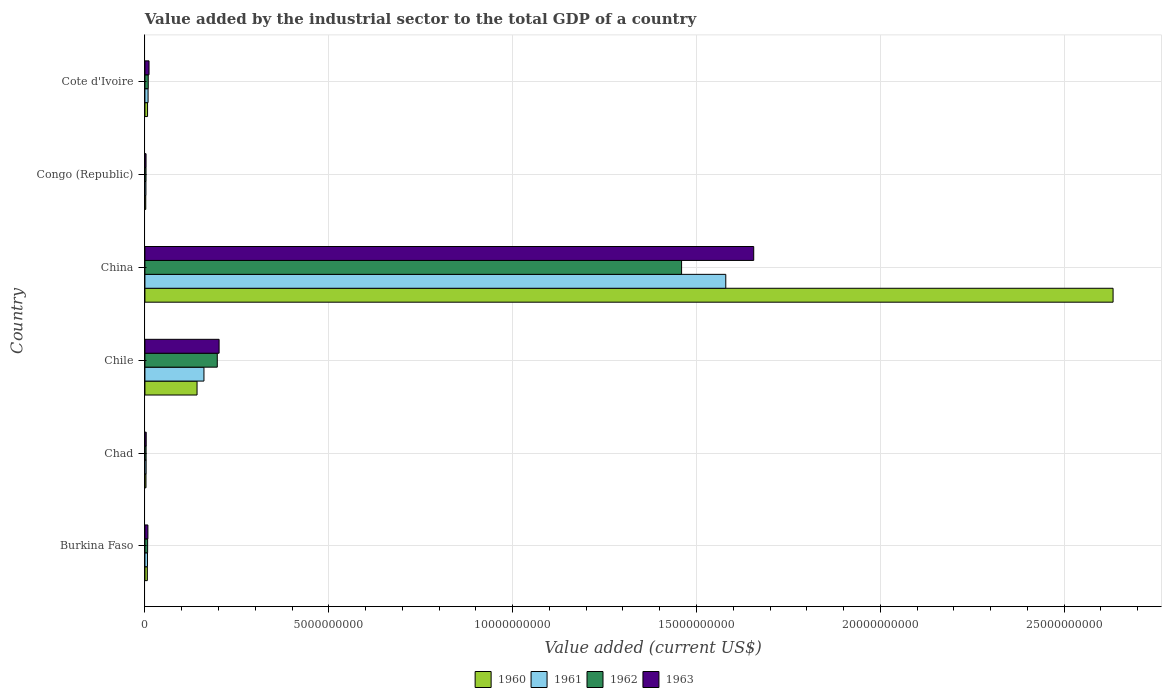Are the number of bars per tick equal to the number of legend labels?
Give a very brief answer. Yes. How many bars are there on the 5th tick from the bottom?
Ensure brevity in your answer.  4. What is the label of the 1st group of bars from the top?
Provide a succinct answer. Cote d'Ivoire. What is the value added by the industrial sector to the total GDP in 1963 in Chile?
Offer a very short reply. 2.02e+09. Across all countries, what is the maximum value added by the industrial sector to the total GDP in 1960?
Make the answer very short. 2.63e+1. Across all countries, what is the minimum value added by the industrial sector to the total GDP in 1961?
Your answer should be compact. 2.73e+07. In which country was the value added by the industrial sector to the total GDP in 1963 maximum?
Your response must be concise. China. In which country was the value added by the industrial sector to the total GDP in 1963 minimum?
Provide a succinct answer. Congo (Republic). What is the total value added by the industrial sector to the total GDP in 1961 in the graph?
Offer a very short reply. 1.76e+1. What is the difference between the value added by the industrial sector to the total GDP in 1963 in Chad and that in Chile?
Your answer should be very brief. -1.98e+09. What is the difference between the value added by the industrial sector to the total GDP in 1963 in Cote d'Ivoire and the value added by the industrial sector to the total GDP in 1961 in Burkina Faso?
Your response must be concise. 4.22e+07. What is the average value added by the industrial sector to the total GDP in 1962 per country?
Make the answer very short. 2.80e+09. What is the difference between the value added by the industrial sector to the total GDP in 1961 and value added by the industrial sector to the total GDP in 1962 in Chile?
Offer a terse response. -3.63e+08. What is the ratio of the value added by the industrial sector to the total GDP in 1962 in Chad to that in Chile?
Your response must be concise. 0.02. Is the difference between the value added by the industrial sector to the total GDP in 1961 in Burkina Faso and China greater than the difference between the value added by the industrial sector to the total GDP in 1962 in Burkina Faso and China?
Offer a very short reply. No. What is the difference between the highest and the second highest value added by the industrial sector to the total GDP in 1960?
Make the answer very short. 2.49e+1. What is the difference between the highest and the lowest value added by the industrial sector to the total GDP in 1962?
Your answer should be compact. 1.46e+1. Is the sum of the value added by the industrial sector to the total GDP in 1963 in Chad and Cote d'Ivoire greater than the maximum value added by the industrial sector to the total GDP in 1960 across all countries?
Make the answer very short. No. What does the 4th bar from the top in Chad represents?
Offer a very short reply. 1960. Is it the case that in every country, the sum of the value added by the industrial sector to the total GDP in 1963 and value added by the industrial sector to the total GDP in 1961 is greater than the value added by the industrial sector to the total GDP in 1962?
Offer a terse response. Yes. How many bars are there?
Provide a succinct answer. 24. How many countries are there in the graph?
Give a very brief answer. 6. What is the difference between two consecutive major ticks on the X-axis?
Your answer should be very brief. 5.00e+09. Are the values on the major ticks of X-axis written in scientific E-notation?
Your response must be concise. No. Does the graph contain any zero values?
Give a very brief answer. No. Does the graph contain grids?
Ensure brevity in your answer.  Yes. How many legend labels are there?
Keep it short and to the point. 4. What is the title of the graph?
Keep it short and to the point. Value added by the industrial sector to the total GDP of a country. What is the label or title of the X-axis?
Your answer should be compact. Value added (current US$). What is the label or title of the Y-axis?
Your answer should be very brief. Country. What is the Value added (current US$) of 1960 in Burkina Faso?
Your answer should be compact. 6.58e+07. What is the Value added (current US$) of 1961 in Burkina Faso?
Make the answer very short. 6.97e+07. What is the Value added (current US$) of 1962 in Burkina Faso?
Offer a terse response. 7.35e+07. What is the Value added (current US$) in 1963 in Burkina Faso?
Ensure brevity in your answer.  8.13e+07. What is the Value added (current US$) of 1960 in Chad?
Your answer should be very brief. 2.88e+07. What is the Value added (current US$) of 1961 in Chad?
Provide a short and direct response. 3.27e+07. What is the Value added (current US$) of 1962 in Chad?
Your answer should be very brief. 3.17e+07. What is the Value added (current US$) in 1963 in Chad?
Ensure brevity in your answer.  3.49e+07. What is the Value added (current US$) of 1960 in Chile?
Your answer should be compact. 1.42e+09. What is the Value added (current US$) of 1961 in Chile?
Your response must be concise. 1.61e+09. What is the Value added (current US$) in 1962 in Chile?
Your response must be concise. 1.97e+09. What is the Value added (current US$) in 1963 in Chile?
Provide a succinct answer. 2.02e+09. What is the Value added (current US$) in 1960 in China?
Make the answer very short. 2.63e+1. What is the Value added (current US$) of 1961 in China?
Offer a very short reply. 1.58e+1. What is the Value added (current US$) in 1962 in China?
Keep it short and to the point. 1.46e+1. What is the Value added (current US$) in 1963 in China?
Offer a very short reply. 1.66e+1. What is the Value added (current US$) in 1960 in Congo (Republic)?
Ensure brevity in your answer.  2.24e+07. What is the Value added (current US$) of 1961 in Congo (Republic)?
Offer a very short reply. 2.73e+07. What is the Value added (current US$) of 1962 in Congo (Republic)?
Make the answer very short. 2.98e+07. What is the Value added (current US$) of 1963 in Congo (Republic)?
Keep it short and to the point. 3.06e+07. What is the Value added (current US$) in 1960 in Cote d'Ivoire?
Provide a succinct answer. 7.18e+07. What is the Value added (current US$) of 1961 in Cote d'Ivoire?
Your response must be concise. 8.58e+07. What is the Value added (current US$) of 1962 in Cote d'Ivoire?
Offer a terse response. 9.02e+07. What is the Value added (current US$) of 1963 in Cote d'Ivoire?
Provide a succinct answer. 1.12e+08. Across all countries, what is the maximum Value added (current US$) of 1960?
Your answer should be very brief. 2.63e+1. Across all countries, what is the maximum Value added (current US$) in 1961?
Your answer should be very brief. 1.58e+1. Across all countries, what is the maximum Value added (current US$) in 1962?
Provide a succinct answer. 1.46e+1. Across all countries, what is the maximum Value added (current US$) in 1963?
Keep it short and to the point. 1.66e+1. Across all countries, what is the minimum Value added (current US$) of 1960?
Ensure brevity in your answer.  2.24e+07. Across all countries, what is the minimum Value added (current US$) of 1961?
Your response must be concise. 2.73e+07. Across all countries, what is the minimum Value added (current US$) of 1962?
Offer a very short reply. 2.98e+07. Across all countries, what is the minimum Value added (current US$) in 1963?
Provide a short and direct response. 3.06e+07. What is the total Value added (current US$) in 1960 in the graph?
Provide a short and direct response. 2.79e+1. What is the total Value added (current US$) in 1961 in the graph?
Your answer should be very brief. 1.76e+1. What is the total Value added (current US$) in 1962 in the graph?
Provide a short and direct response. 1.68e+1. What is the total Value added (current US$) of 1963 in the graph?
Provide a succinct answer. 1.88e+1. What is the difference between the Value added (current US$) of 1960 in Burkina Faso and that in Chad?
Offer a very short reply. 3.70e+07. What is the difference between the Value added (current US$) of 1961 in Burkina Faso and that in Chad?
Provide a succinct answer. 3.70e+07. What is the difference between the Value added (current US$) of 1962 in Burkina Faso and that in Chad?
Keep it short and to the point. 4.18e+07. What is the difference between the Value added (current US$) of 1963 in Burkina Faso and that in Chad?
Your answer should be compact. 4.64e+07. What is the difference between the Value added (current US$) in 1960 in Burkina Faso and that in Chile?
Offer a terse response. -1.35e+09. What is the difference between the Value added (current US$) of 1961 in Burkina Faso and that in Chile?
Provide a succinct answer. -1.54e+09. What is the difference between the Value added (current US$) of 1962 in Burkina Faso and that in Chile?
Make the answer very short. -1.89e+09. What is the difference between the Value added (current US$) in 1963 in Burkina Faso and that in Chile?
Provide a short and direct response. -1.94e+09. What is the difference between the Value added (current US$) of 1960 in Burkina Faso and that in China?
Provide a short and direct response. -2.63e+1. What is the difference between the Value added (current US$) in 1961 in Burkina Faso and that in China?
Your response must be concise. -1.57e+1. What is the difference between the Value added (current US$) of 1962 in Burkina Faso and that in China?
Provide a short and direct response. -1.45e+1. What is the difference between the Value added (current US$) in 1963 in Burkina Faso and that in China?
Offer a terse response. -1.65e+1. What is the difference between the Value added (current US$) in 1960 in Burkina Faso and that in Congo (Republic)?
Provide a succinct answer. 4.34e+07. What is the difference between the Value added (current US$) in 1961 in Burkina Faso and that in Congo (Republic)?
Your answer should be compact. 4.24e+07. What is the difference between the Value added (current US$) in 1962 in Burkina Faso and that in Congo (Republic)?
Provide a short and direct response. 4.37e+07. What is the difference between the Value added (current US$) of 1963 in Burkina Faso and that in Congo (Republic)?
Your answer should be compact. 5.07e+07. What is the difference between the Value added (current US$) of 1960 in Burkina Faso and that in Cote d'Ivoire?
Your answer should be very brief. -5.96e+06. What is the difference between the Value added (current US$) in 1961 in Burkina Faso and that in Cote d'Ivoire?
Provide a succinct answer. -1.61e+07. What is the difference between the Value added (current US$) in 1962 in Burkina Faso and that in Cote d'Ivoire?
Ensure brevity in your answer.  -1.67e+07. What is the difference between the Value added (current US$) of 1963 in Burkina Faso and that in Cote d'Ivoire?
Make the answer very short. -3.06e+07. What is the difference between the Value added (current US$) of 1960 in Chad and that in Chile?
Offer a terse response. -1.39e+09. What is the difference between the Value added (current US$) of 1961 in Chad and that in Chile?
Provide a succinct answer. -1.57e+09. What is the difference between the Value added (current US$) of 1962 in Chad and that in Chile?
Your answer should be compact. -1.94e+09. What is the difference between the Value added (current US$) of 1963 in Chad and that in Chile?
Offer a very short reply. -1.98e+09. What is the difference between the Value added (current US$) of 1960 in Chad and that in China?
Make the answer very short. -2.63e+1. What is the difference between the Value added (current US$) of 1961 in Chad and that in China?
Provide a succinct answer. -1.58e+1. What is the difference between the Value added (current US$) of 1962 in Chad and that in China?
Keep it short and to the point. -1.46e+1. What is the difference between the Value added (current US$) of 1963 in Chad and that in China?
Ensure brevity in your answer.  -1.65e+1. What is the difference between the Value added (current US$) in 1960 in Chad and that in Congo (Republic)?
Ensure brevity in your answer.  6.40e+06. What is the difference between the Value added (current US$) of 1961 in Chad and that in Congo (Republic)?
Ensure brevity in your answer.  5.34e+06. What is the difference between the Value added (current US$) of 1962 in Chad and that in Congo (Republic)?
Your answer should be very brief. 1.94e+06. What is the difference between the Value added (current US$) of 1963 in Chad and that in Congo (Republic)?
Make the answer very short. 4.26e+06. What is the difference between the Value added (current US$) in 1960 in Chad and that in Cote d'Ivoire?
Ensure brevity in your answer.  -4.29e+07. What is the difference between the Value added (current US$) in 1961 in Chad and that in Cote d'Ivoire?
Keep it short and to the point. -5.32e+07. What is the difference between the Value added (current US$) of 1962 in Chad and that in Cote d'Ivoire?
Provide a succinct answer. -5.85e+07. What is the difference between the Value added (current US$) in 1963 in Chad and that in Cote d'Ivoire?
Offer a very short reply. -7.70e+07. What is the difference between the Value added (current US$) in 1960 in Chile and that in China?
Provide a succinct answer. -2.49e+1. What is the difference between the Value added (current US$) in 1961 in Chile and that in China?
Your answer should be compact. -1.42e+1. What is the difference between the Value added (current US$) of 1962 in Chile and that in China?
Provide a short and direct response. -1.26e+1. What is the difference between the Value added (current US$) of 1963 in Chile and that in China?
Keep it short and to the point. -1.45e+1. What is the difference between the Value added (current US$) of 1960 in Chile and that in Congo (Republic)?
Give a very brief answer. 1.40e+09. What is the difference between the Value added (current US$) of 1961 in Chile and that in Congo (Republic)?
Ensure brevity in your answer.  1.58e+09. What is the difference between the Value added (current US$) of 1962 in Chile and that in Congo (Republic)?
Your response must be concise. 1.94e+09. What is the difference between the Value added (current US$) of 1963 in Chile and that in Congo (Republic)?
Provide a succinct answer. 1.99e+09. What is the difference between the Value added (current US$) of 1960 in Chile and that in Cote d'Ivoire?
Your answer should be very brief. 1.35e+09. What is the difference between the Value added (current US$) of 1961 in Chile and that in Cote d'Ivoire?
Offer a terse response. 1.52e+09. What is the difference between the Value added (current US$) in 1962 in Chile and that in Cote d'Ivoire?
Make the answer very short. 1.88e+09. What is the difference between the Value added (current US$) in 1963 in Chile and that in Cote d'Ivoire?
Give a very brief answer. 1.91e+09. What is the difference between the Value added (current US$) of 1960 in China and that in Congo (Republic)?
Keep it short and to the point. 2.63e+1. What is the difference between the Value added (current US$) of 1961 in China and that in Congo (Republic)?
Your answer should be very brief. 1.58e+1. What is the difference between the Value added (current US$) of 1962 in China and that in Congo (Republic)?
Your answer should be very brief. 1.46e+1. What is the difference between the Value added (current US$) in 1963 in China and that in Congo (Republic)?
Provide a succinct answer. 1.65e+1. What is the difference between the Value added (current US$) of 1960 in China and that in Cote d'Ivoire?
Your answer should be very brief. 2.63e+1. What is the difference between the Value added (current US$) in 1961 in China and that in Cote d'Ivoire?
Your answer should be compact. 1.57e+1. What is the difference between the Value added (current US$) in 1962 in China and that in Cote d'Ivoire?
Provide a short and direct response. 1.45e+1. What is the difference between the Value added (current US$) in 1963 in China and that in Cote d'Ivoire?
Provide a short and direct response. 1.64e+1. What is the difference between the Value added (current US$) in 1960 in Congo (Republic) and that in Cote d'Ivoire?
Offer a terse response. -4.93e+07. What is the difference between the Value added (current US$) in 1961 in Congo (Republic) and that in Cote d'Ivoire?
Make the answer very short. -5.85e+07. What is the difference between the Value added (current US$) of 1962 in Congo (Republic) and that in Cote d'Ivoire?
Give a very brief answer. -6.04e+07. What is the difference between the Value added (current US$) in 1963 in Congo (Republic) and that in Cote d'Ivoire?
Make the answer very short. -8.13e+07. What is the difference between the Value added (current US$) of 1960 in Burkina Faso and the Value added (current US$) of 1961 in Chad?
Your answer should be very brief. 3.32e+07. What is the difference between the Value added (current US$) of 1960 in Burkina Faso and the Value added (current US$) of 1962 in Chad?
Your answer should be compact. 3.41e+07. What is the difference between the Value added (current US$) of 1960 in Burkina Faso and the Value added (current US$) of 1963 in Chad?
Your response must be concise. 3.09e+07. What is the difference between the Value added (current US$) in 1961 in Burkina Faso and the Value added (current US$) in 1962 in Chad?
Your response must be concise. 3.79e+07. What is the difference between the Value added (current US$) in 1961 in Burkina Faso and the Value added (current US$) in 1963 in Chad?
Provide a succinct answer. 3.48e+07. What is the difference between the Value added (current US$) of 1962 in Burkina Faso and the Value added (current US$) of 1963 in Chad?
Give a very brief answer. 3.86e+07. What is the difference between the Value added (current US$) of 1960 in Burkina Faso and the Value added (current US$) of 1961 in Chile?
Offer a terse response. -1.54e+09. What is the difference between the Value added (current US$) of 1960 in Burkina Faso and the Value added (current US$) of 1962 in Chile?
Offer a terse response. -1.90e+09. What is the difference between the Value added (current US$) in 1960 in Burkina Faso and the Value added (current US$) in 1963 in Chile?
Your answer should be very brief. -1.95e+09. What is the difference between the Value added (current US$) of 1961 in Burkina Faso and the Value added (current US$) of 1962 in Chile?
Offer a very short reply. -1.90e+09. What is the difference between the Value added (current US$) of 1961 in Burkina Faso and the Value added (current US$) of 1963 in Chile?
Your answer should be compact. -1.95e+09. What is the difference between the Value added (current US$) in 1962 in Burkina Faso and the Value added (current US$) in 1963 in Chile?
Give a very brief answer. -1.94e+09. What is the difference between the Value added (current US$) of 1960 in Burkina Faso and the Value added (current US$) of 1961 in China?
Ensure brevity in your answer.  -1.57e+1. What is the difference between the Value added (current US$) in 1960 in Burkina Faso and the Value added (current US$) in 1962 in China?
Give a very brief answer. -1.45e+1. What is the difference between the Value added (current US$) in 1960 in Burkina Faso and the Value added (current US$) in 1963 in China?
Make the answer very short. -1.65e+1. What is the difference between the Value added (current US$) in 1961 in Burkina Faso and the Value added (current US$) in 1962 in China?
Provide a succinct answer. -1.45e+1. What is the difference between the Value added (current US$) of 1961 in Burkina Faso and the Value added (current US$) of 1963 in China?
Keep it short and to the point. -1.65e+1. What is the difference between the Value added (current US$) of 1962 in Burkina Faso and the Value added (current US$) of 1963 in China?
Your response must be concise. -1.65e+1. What is the difference between the Value added (current US$) of 1960 in Burkina Faso and the Value added (current US$) of 1961 in Congo (Republic)?
Make the answer very short. 3.85e+07. What is the difference between the Value added (current US$) in 1960 in Burkina Faso and the Value added (current US$) in 1962 in Congo (Republic)?
Provide a short and direct response. 3.60e+07. What is the difference between the Value added (current US$) in 1960 in Burkina Faso and the Value added (current US$) in 1963 in Congo (Republic)?
Ensure brevity in your answer.  3.52e+07. What is the difference between the Value added (current US$) in 1961 in Burkina Faso and the Value added (current US$) in 1962 in Congo (Republic)?
Keep it short and to the point. 3.99e+07. What is the difference between the Value added (current US$) of 1961 in Burkina Faso and the Value added (current US$) of 1963 in Congo (Republic)?
Your response must be concise. 3.91e+07. What is the difference between the Value added (current US$) of 1962 in Burkina Faso and the Value added (current US$) of 1963 in Congo (Republic)?
Provide a succinct answer. 4.29e+07. What is the difference between the Value added (current US$) in 1960 in Burkina Faso and the Value added (current US$) in 1961 in Cote d'Ivoire?
Make the answer very short. -2.00e+07. What is the difference between the Value added (current US$) in 1960 in Burkina Faso and the Value added (current US$) in 1962 in Cote d'Ivoire?
Give a very brief answer. -2.44e+07. What is the difference between the Value added (current US$) of 1960 in Burkina Faso and the Value added (current US$) of 1963 in Cote d'Ivoire?
Make the answer very short. -4.61e+07. What is the difference between the Value added (current US$) in 1961 in Burkina Faso and the Value added (current US$) in 1962 in Cote d'Ivoire?
Ensure brevity in your answer.  -2.05e+07. What is the difference between the Value added (current US$) in 1961 in Burkina Faso and the Value added (current US$) in 1963 in Cote d'Ivoire?
Your answer should be very brief. -4.22e+07. What is the difference between the Value added (current US$) in 1962 in Burkina Faso and the Value added (current US$) in 1963 in Cote d'Ivoire?
Your response must be concise. -3.84e+07. What is the difference between the Value added (current US$) of 1960 in Chad and the Value added (current US$) of 1961 in Chile?
Your answer should be compact. -1.58e+09. What is the difference between the Value added (current US$) of 1960 in Chad and the Value added (current US$) of 1962 in Chile?
Offer a very short reply. -1.94e+09. What is the difference between the Value added (current US$) of 1960 in Chad and the Value added (current US$) of 1963 in Chile?
Make the answer very short. -1.99e+09. What is the difference between the Value added (current US$) of 1961 in Chad and the Value added (current US$) of 1962 in Chile?
Your answer should be very brief. -1.94e+09. What is the difference between the Value added (current US$) in 1961 in Chad and the Value added (current US$) in 1963 in Chile?
Provide a succinct answer. -1.98e+09. What is the difference between the Value added (current US$) of 1962 in Chad and the Value added (current US$) of 1963 in Chile?
Your answer should be compact. -1.99e+09. What is the difference between the Value added (current US$) of 1960 in Chad and the Value added (current US$) of 1961 in China?
Keep it short and to the point. -1.58e+1. What is the difference between the Value added (current US$) in 1960 in Chad and the Value added (current US$) in 1962 in China?
Ensure brevity in your answer.  -1.46e+1. What is the difference between the Value added (current US$) in 1960 in Chad and the Value added (current US$) in 1963 in China?
Keep it short and to the point. -1.65e+1. What is the difference between the Value added (current US$) in 1961 in Chad and the Value added (current US$) in 1962 in China?
Make the answer very short. -1.46e+1. What is the difference between the Value added (current US$) in 1961 in Chad and the Value added (current US$) in 1963 in China?
Ensure brevity in your answer.  -1.65e+1. What is the difference between the Value added (current US$) of 1962 in Chad and the Value added (current US$) of 1963 in China?
Provide a short and direct response. -1.65e+1. What is the difference between the Value added (current US$) in 1960 in Chad and the Value added (current US$) in 1961 in Congo (Republic)?
Your answer should be compact. 1.52e+06. What is the difference between the Value added (current US$) of 1960 in Chad and the Value added (current US$) of 1962 in Congo (Republic)?
Your answer should be compact. -9.61e+05. What is the difference between the Value added (current US$) of 1960 in Chad and the Value added (current US$) of 1963 in Congo (Republic)?
Your answer should be very brief. -1.78e+06. What is the difference between the Value added (current US$) in 1961 in Chad and the Value added (current US$) in 1962 in Congo (Republic)?
Your answer should be very brief. 2.86e+06. What is the difference between the Value added (current US$) in 1961 in Chad and the Value added (current US$) in 1963 in Congo (Republic)?
Provide a succinct answer. 2.04e+06. What is the difference between the Value added (current US$) of 1962 in Chad and the Value added (current US$) of 1963 in Congo (Republic)?
Keep it short and to the point. 1.12e+06. What is the difference between the Value added (current US$) of 1960 in Chad and the Value added (current US$) of 1961 in Cote d'Ivoire?
Provide a succinct answer. -5.70e+07. What is the difference between the Value added (current US$) in 1960 in Chad and the Value added (current US$) in 1962 in Cote d'Ivoire?
Give a very brief answer. -6.14e+07. What is the difference between the Value added (current US$) of 1960 in Chad and the Value added (current US$) of 1963 in Cote d'Ivoire?
Give a very brief answer. -8.30e+07. What is the difference between the Value added (current US$) of 1961 in Chad and the Value added (current US$) of 1962 in Cote d'Ivoire?
Keep it short and to the point. -5.76e+07. What is the difference between the Value added (current US$) of 1961 in Chad and the Value added (current US$) of 1963 in Cote d'Ivoire?
Offer a very short reply. -7.92e+07. What is the difference between the Value added (current US$) in 1962 in Chad and the Value added (current US$) in 1963 in Cote d'Ivoire?
Offer a terse response. -8.01e+07. What is the difference between the Value added (current US$) of 1960 in Chile and the Value added (current US$) of 1961 in China?
Ensure brevity in your answer.  -1.44e+1. What is the difference between the Value added (current US$) in 1960 in Chile and the Value added (current US$) in 1962 in China?
Your response must be concise. -1.32e+1. What is the difference between the Value added (current US$) in 1960 in Chile and the Value added (current US$) in 1963 in China?
Provide a short and direct response. -1.51e+1. What is the difference between the Value added (current US$) in 1961 in Chile and the Value added (current US$) in 1962 in China?
Your answer should be very brief. -1.30e+1. What is the difference between the Value added (current US$) of 1961 in Chile and the Value added (current US$) of 1963 in China?
Give a very brief answer. -1.50e+1. What is the difference between the Value added (current US$) in 1962 in Chile and the Value added (current US$) in 1963 in China?
Your answer should be very brief. -1.46e+1. What is the difference between the Value added (current US$) in 1960 in Chile and the Value added (current US$) in 1961 in Congo (Republic)?
Offer a terse response. 1.39e+09. What is the difference between the Value added (current US$) of 1960 in Chile and the Value added (current US$) of 1962 in Congo (Republic)?
Keep it short and to the point. 1.39e+09. What is the difference between the Value added (current US$) of 1960 in Chile and the Value added (current US$) of 1963 in Congo (Republic)?
Keep it short and to the point. 1.39e+09. What is the difference between the Value added (current US$) of 1961 in Chile and the Value added (current US$) of 1962 in Congo (Republic)?
Provide a succinct answer. 1.58e+09. What is the difference between the Value added (current US$) in 1961 in Chile and the Value added (current US$) in 1963 in Congo (Republic)?
Ensure brevity in your answer.  1.57e+09. What is the difference between the Value added (current US$) of 1962 in Chile and the Value added (current US$) of 1963 in Congo (Republic)?
Offer a terse response. 1.94e+09. What is the difference between the Value added (current US$) of 1960 in Chile and the Value added (current US$) of 1961 in Cote d'Ivoire?
Provide a succinct answer. 1.33e+09. What is the difference between the Value added (current US$) of 1960 in Chile and the Value added (current US$) of 1962 in Cote d'Ivoire?
Your response must be concise. 1.33e+09. What is the difference between the Value added (current US$) in 1960 in Chile and the Value added (current US$) in 1963 in Cote d'Ivoire?
Your answer should be very brief. 1.31e+09. What is the difference between the Value added (current US$) in 1961 in Chile and the Value added (current US$) in 1962 in Cote d'Ivoire?
Your response must be concise. 1.52e+09. What is the difference between the Value added (current US$) in 1961 in Chile and the Value added (current US$) in 1963 in Cote d'Ivoire?
Make the answer very short. 1.49e+09. What is the difference between the Value added (current US$) in 1962 in Chile and the Value added (current US$) in 1963 in Cote d'Ivoire?
Your answer should be compact. 1.86e+09. What is the difference between the Value added (current US$) in 1960 in China and the Value added (current US$) in 1961 in Congo (Republic)?
Provide a short and direct response. 2.63e+1. What is the difference between the Value added (current US$) of 1960 in China and the Value added (current US$) of 1962 in Congo (Republic)?
Offer a very short reply. 2.63e+1. What is the difference between the Value added (current US$) in 1960 in China and the Value added (current US$) in 1963 in Congo (Republic)?
Your response must be concise. 2.63e+1. What is the difference between the Value added (current US$) of 1961 in China and the Value added (current US$) of 1962 in Congo (Republic)?
Your response must be concise. 1.58e+1. What is the difference between the Value added (current US$) in 1961 in China and the Value added (current US$) in 1963 in Congo (Republic)?
Your answer should be compact. 1.58e+1. What is the difference between the Value added (current US$) in 1962 in China and the Value added (current US$) in 1963 in Congo (Republic)?
Keep it short and to the point. 1.46e+1. What is the difference between the Value added (current US$) of 1960 in China and the Value added (current US$) of 1961 in Cote d'Ivoire?
Your answer should be compact. 2.62e+1. What is the difference between the Value added (current US$) in 1960 in China and the Value added (current US$) in 1962 in Cote d'Ivoire?
Keep it short and to the point. 2.62e+1. What is the difference between the Value added (current US$) of 1960 in China and the Value added (current US$) of 1963 in Cote d'Ivoire?
Your response must be concise. 2.62e+1. What is the difference between the Value added (current US$) in 1961 in China and the Value added (current US$) in 1962 in Cote d'Ivoire?
Make the answer very short. 1.57e+1. What is the difference between the Value added (current US$) in 1961 in China and the Value added (current US$) in 1963 in Cote d'Ivoire?
Offer a very short reply. 1.57e+1. What is the difference between the Value added (current US$) of 1962 in China and the Value added (current US$) of 1963 in Cote d'Ivoire?
Offer a very short reply. 1.45e+1. What is the difference between the Value added (current US$) of 1960 in Congo (Republic) and the Value added (current US$) of 1961 in Cote d'Ivoire?
Your answer should be compact. -6.34e+07. What is the difference between the Value added (current US$) in 1960 in Congo (Republic) and the Value added (current US$) in 1962 in Cote d'Ivoire?
Your answer should be very brief. -6.78e+07. What is the difference between the Value added (current US$) of 1960 in Congo (Republic) and the Value added (current US$) of 1963 in Cote d'Ivoire?
Your response must be concise. -8.94e+07. What is the difference between the Value added (current US$) in 1961 in Congo (Republic) and the Value added (current US$) in 1962 in Cote d'Ivoire?
Ensure brevity in your answer.  -6.29e+07. What is the difference between the Value added (current US$) in 1961 in Congo (Republic) and the Value added (current US$) in 1963 in Cote d'Ivoire?
Offer a terse response. -8.46e+07. What is the difference between the Value added (current US$) in 1962 in Congo (Republic) and the Value added (current US$) in 1963 in Cote d'Ivoire?
Your answer should be very brief. -8.21e+07. What is the average Value added (current US$) in 1960 per country?
Ensure brevity in your answer.  4.66e+09. What is the average Value added (current US$) in 1961 per country?
Your response must be concise. 2.94e+09. What is the average Value added (current US$) in 1962 per country?
Your answer should be very brief. 2.80e+09. What is the average Value added (current US$) in 1963 per country?
Your response must be concise. 3.14e+09. What is the difference between the Value added (current US$) in 1960 and Value added (current US$) in 1961 in Burkina Faso?
Offer a terse response. -3.88e+06. What is the difference between the Value added (current US$) in 1960 and Value added (current US$) in 1962 in Burkina Faso?
Ensure brevity in your answer.  -7.71e+06. What is the difference between the Value added (current US$) of 1960 and Value added (current US$) of 1963 in Burkina Faso?
Provide a succinct answer. -1.55e+07. What is the difference between the Value added (current US$) of 1961 and Value added (current US$) of 1962 in Burkina Faso?
Your response must be concise. -3.83e+06. What is the difference between the Value added (current US$) in 1961 and Value added (current US$) in 1963 in Burkina Faso?
Make the answer very short. -1.16e+07. What is the difference between the Value added (current US$) of 1962 and Value added (current US$) of 1963 in Burkina Faso?
Give a very brief answer. -7.75e+06. What is the difference between the Value added (current US$) of 1960 and Value added (current US$) of 1961 in Chad?
Ensure brevity in your answer.  -3.82e+06. What is the difference between the Value added (current US$) in 1960 and Value added (current US$) in 1962 in Chad?
Ensure brevity in your answer.  -2.90e+06. What is the difference between the Value added (current US$) in 1960 and Value added (current US$) in 1963 in Chad?
Make the answer very short. -6.04e+06. What is the difference between the Value added (current US$) in 1961 and Value added (current US$) in 1962 in Chad?
Provide a short and direct response. 9.19e+05. What is the difference between the Value added (current US$) of 1961 and Value added (current US$) of 1963 in Chad?
Give a very brief answer. -2.22e+06. What is the difference between the Value added (current US$) of 1962 and Value added (current US$) of 1963 in Chad?
Offer a terse response. -3.14e+06. What is the difference between the Value added (current US$) in 1960 and Value added (current US$) in 1961 in Chile?
Your answer should be very brief. -1.88e+08. What is the difference between the Value added (current US$) in 1960 and Value added (current US$) in 1962 in Chile?
Your response must be concise. -5.50e+08. What is the difference between the Value added (current US$) of 1960 and Value added (current US$) of 1963 in Chile?
Ensure brevity in your answer.  -5.99e+08. What is the difference between the Value added (current US$) of 1961 and Value added (current US$) of 1962 in Chile?
Keep it short and to the point. -3.63e+08. What is the difference between the Value added (current US$) of 1961 and Value added (current US$) of 1963 in Chile?
Give a very brief answer. -4.12e+08. What is the difference between the Value added (current US$) in 1962 and Value added (current US$) in 1963 in Chile?
Provide a short and direct response. -4.92e+07. What is the difference between the Value added (current US$) in 1960 and Value added (current US$) in 1961 in China?
Keep it short and to the point. 1.05e+1. What is the difference between the Value added (current US$) of 1960 and Value added (current US$) of 1962 in China?
Make the answer very short. 1.17e+1. What is the difference between the Value added (current US$) in 1960 and Value added (current US$) in 1963 in China?
Your answer should be very brief. 9.77e+09. What is the difference between the Value added (current US$) in 1961 and Value added (current US$) in 1962 in China?
Keep it short and to the point. 1.20e+09. What is the difference between the Value added (current US$) in 1961 and Value added (current US$) in 1963 in China?
Provide a short and direct response. -7.60e+08. What is the difference between the Value added (current US$) of 1962 and Value added (current US$) of 1963 in China?
Your answer should be very brief. -1.96e+09. What is the difference between the Value added (current US$) in 1960 and Value added (current US$) in 1961 in Congo (Republic)?
Make the answer very short. -4.89e+06. What is the difference between the Value added (current US$) of 1960 and Value added (current US$) of 1962 in Congo (Republic)?
Offer a very short reply. -7.36e+06. What is the difference between the Value added (current US$) in 1960 and Value added (current US$) in 1963 in Congo (Republic)?
Offer a very short reply. -8.18e+06. What is the difference between the Value added (current US$) of 1961 and Value added (current US$) of 1962 in Congo (Republic)?
Your response must be concise. -2.48e+06. What is the difference between the Value added (current US$) of 1961 and Value added (current US$) of 1963 in Congo (Republic)?
Provide a succinct answer. -3.29e+06. What is the difference between the Value added (current US$) of 1962 and Value added (current US$) of 1963 in Congo (Republic)?
Your answer should be compact. -8.16e+05. What is the difference between the Value added (current US$) in 1960 and Value added (current US$) in 1961 in Cote d'Ivoire?
Your answer should be very brief. -1.40e+07. What is the difference between the Value added (current US$) in 1960 and Value added (current US$) in 1962 in Cote d'Ivoire?
Make the answer very short. -1.85e+07. What is the difference between the Value added (current US$) of 1960 and Value added (current US$) of 1963 in Cote d'Ivoire?
Your answer should be very brief. -4.01e+07. What is the difference between the Value added (current US$) in 1961 and Value added (current US$) in 1962 in Cote d'Ivoire?
Your answer should be very brief. -4.42e+06. What is the difference between the Value added (current US$) in 1961 and Value added (current US$) in 1963 in Cote d'Ivoire?
Offer a very short reply. -2.61e+07. What is the difference between the Value added (current US$) in 1962 and Value added (current US$) in 1963 in Cote d'Ivoire?
Make the answer very short. -2.17e+07. What is the ratio of the Value added (current US$) of 1960 in Burkina Faso to that in Chad?
Offer a terse response. 2.28. What is the ratio of the Value added (current US$) of 1961 in Burkina Faso to that in Chad?
Ensure brevity in your answer.  2.13. What is the ratio of the Value added (current US$) in 1962 in Burkina Faso to that in Chad?
Keep it short and to the point. 2.32. What is the ratio of the Value added (current US$) of 1963 in Burkina Faso to that in Chad?
Ensure brevity in your answer.  2.33. What is the ratio of the Value added (current US$) in 1960 in Burkina Faso to that in Chile?
Provide a succinct answer. 0.05. What is the ratio of the Value added (current US$) of 1961 in Burkina Faso to that in Chile?
Give a very brief answer. 0.04. What is the ratio of the Value added (current US$) in 1962 in Burkina Faso to that in Chile?
Offer a terse response. 0.04. What is the ratio of the Value added (current US$) of 1963 in Burkina Faso to that in Chile?
Provide a succinct answer. 0.04. What is the ratio of the Value added (current US$) of 1960 in Burkina Faso to that in China?
Your answer should be very brief. 0. What is the ratio of the Value added (current US$) of 1961 in Burkina Faso to that in China?
Your response must be concise. 0. What is the ratio of the Value added (current US$) of 1962 in Burkina Faso to that in China?
Ensure brevity in your answer.  0.01. What is the ratio of the Value added (current US$) in 1963 in Burkina Faso to that in China?
Provide a succinct answer. 0. What is the ratio of the Value added (current US$) of 1960 in Burkina Faso to that in Congo (Republic)?
Offer a very short reply. 2.93. What is the ratio of the Value added (current US$) in 1961 in Burkina Faso to that in Congo (Republic)?
Provide a succinct answer. 2.55. What is the ratio of the Value added (current US$) in 1962 in Burkina Faso to that in Congo (Republic)?
Offer a very short reply. 2.47. What is the ratio of the Value added (current US$) of 1963 in Burkina Faso to that in Congo (Republic)?
Offer a terse response. 2.65. What is the ratio of the Value added (current US$) of 1960 in Burkina Faso to that in Cote d'Ivoire?
Provide a succinct answer. 0.92. What is the ratio of the Value added (current US$) in 1961 in Burkina Faso to that in Cote d'Ivoire?
Make the answer very short. 0.81. What is the ratio of the Value added (current US$) of 1962 in Burkina Faso to that in Cote d'Ivoire?
Provide a succinct answer. 0.81. What is the ratio of the Value added (current US$) in 1963 in Burkina Faso to that in Cote d'Ivoire?
Your response must be concise. 0.73. What is the ratio of the Value added (current US$) of 1960 in Chad to that in Chile?
Offer a very short reply. 0.02. What is the ratio of the Value added (current US$) of 1961 in Chad to that in Chile?
Your response must be concise. 0.02. What is the ratio of the Value added (current US$) of 1962 in Chad to that in Chile?
Give a very brief answer. 0.02. What is the ratio of the Value added (current US$) in 1963 in Chad to that in Chile?
Offer a very short reply. 0.02. What is the ratio of the Value added (current US$) in 1960 in Chad to that in China?
Make the answer very short. 0. What is the ratio of the Value added (current US$) of 1961 in Chad to that in China?
Keep it short and to the point. 0. What is the ratio of the Value added (current US$) in 1962 in Chad to that in China?
Give a very brief answer. 0. What is the ratio of the Value added (current US$) in 1963 in Chad to that in China?
Offer a very short reply. 0. What is the ratio of the Value added (current US$) in 1960 in Chad to that in Congo (Republic)?
Keep it short and to the point. 1.29. What is the ratio of the Value added (current US$) in 1961 in Chad to that in Congo (Republic)?
Offer a very short reply. 1.2. What is the ratio of the Value added (current US$) of 1962 in Chad to that in Congo (Republic)?
Provide a short and direct response. 1.07. What is the ratio of the Value added (current US$) in 1963 in Chad to that in Congo (Republic)?
Provide a short and direct response. 1.14. What is the ratio of the Value added (current US$) in 1960 in Chad to that in Cote d'Ivoire?
Keep it short and to the point. 0.4. What is the ratio of the Value added (current US$) in 1961 in Chad to that in Cote d'Ivoire?
Give a very brief answer. 0.38. What is the ratio of the Value added (current US$) in 1962 in Chad to that in Cote d'Ivoire?
Keep it short and to the point. 0.35. What is the ratio of the Value added (current US$) in 1963 in Chad to that in Cote d'Ivoire?
Your response must be concise. 0.31. What is the ratio of the Value added (current US$) of 1960 in Chile to that in China?
Ensure brevity in your answer.  0.05. What is the ratio of the Value added (current US$) of 1961 in Chile to that in China?
Offer a terse response. 0.1. What is the ratio of the Value added (current US$) in 1962 in Chile to that in China?
Your answer should be very brief. 0.13. What is the ratio of the Value added (current US$) in 1963 in Chile to that in China?
Ensure brevity in your answer.  0.12. What is the ratio of the Value added (current US$) of 1960 in Chile to that in Congo (Republic)?
Provide a succinct answer. 63.21. What is the ratio of the Value added (current US$) of 1961 in Chile to that in Congo (Republic)?
Provide a succinct answer. 58.77. What is the ratio of the Value added (current US$) of 1962 in Chile to that in Congo (Republic)?
Ensure brevity in your answer.  66.06. What is the ratio of the Value added (current US$) of 1963 in Chile to that in Congo (Republic)?
Offer a terse response. 65.9. What is the ratio of the Value added (current US$) in 1960 in Chile to that in Cote d'Ivoire?
Your answer should be very brief. 19.76. What is the ratio of the Value added (current US$) of 1961 in Chile to that in Cote d'Ivoire?
Your response must be concise. 18.71. What is the ratio of the Value added (current US$) in 1962 in Chile to that in Cote d'Ivoire?
Offer a terse response. 21.81. What is the ratio of the Value added (current US$) of 1963 in Chile to that in Cote d'Ivoire?
Offer a very short reply. 18.03. What is the ratio of the Value added (current US$) of 1960 in China to that in Congo (Republic)?
Offer a very short reply. 1173.83. What is the ratio of the Value added (current US$) of 1961 in China to that in Congo (Republic)?
Your answer should be very brief. 578.28. What is the ratio of the Value added (current US$) of 1962 in China to that in Congo (Republic)?
Make the answer very short. 489.86. What is the ratio of the Value added (current US$) in 1963 in China to that in Congo (Republic)?
Your answer should be very brief. 540.9. What is the ratio of the Value added (current US$) in 1960 in China to that in Cote d'Ivoire?
Your answer should be very brief. 366.9. What is the ratio of the Value added (current US$) in 1961 in China to that in Cote d'Ivoire?
Ensure brevity in your answer.  184.1. What is the ratio of the Value added (current US$) of 1962 in China to that in Cote d'Ivoire?
Keep it short and to the point. 161.77. What is the ratio of the Value added (current US$) of 1963 in China to that in Cote d'Ivoire?
Provide a succinct answer. 147.99. What is the ratio of the Value added (current US$) of 1960 in Congo (Republic) to that in Cote d'Ivoire?
Your answer should be compact. 0.31. What is the ratio of the Value added (current US$) of 1961 in Congo (Republic) to that in Cote d'Ivoire?
Your answer should be very brief. 0.32. What is the ratio of the Value added (current US$) of 1962 in Congo (Republic) to that in Cote d'Ivoire?
Your answer should be compact. 0.33. What is the ratio of the Value added (current US$) of 1963 in Congo (Republic) to that in Cote d'Ivoire?
Your answer should be very brief. 0.27. What is the difference between the highest and the second highest Value added (current US$) of 1960?
Your answer should be compact. 2.49e+1. What is the difference between the highest and the second highest Value added (current US$) of 1961?
Offer a terse response. 1.42e+1. What is the difference between the highest and the second highest Value added (current US$) in 1962?
Your answer should be compact. 1.26e+1. What is the difference between the highest and the second highest Value added (current US$) in 1963?
Offer a terse response. 1.45e+1. What is the difference between the highest and the lowest Value added (current US$) of 1960?
Offer a terse response. 2.63e+1. What is the difference between the highest and the lowest Value added (current US$) of 1961?
Provide a short and direct response. 1.58e+1. What is the difference between the highest and the lowest Value added (current US$) in 1962?
Provide a short and direct response. 1.46e+1. What is the difference between the highest and the lowest Value added (current US$) of 1963?
Offer a very short reply. 1.65e+1. 